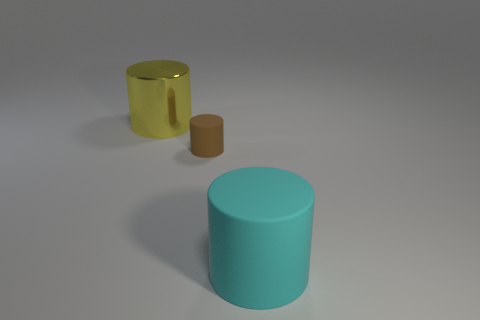Subtract all small cylinders. How many cylinders are left? 2 Add 1 yellow cylinders. How many objects exist? 4 Subtract all brown cylinders. How many cylinders are left? 2 Subtract 2 cylinders. How many cylinders are left? 1 Subtract all small green shiny cylinders. Subtract all large yellow cylinders. How many objects are left? 2 Add 1 rubber cylinders. How many rubber cylinders are left? 3 Add 3 brown rubber objects. How many brown rubber objects exist? 4 Subtract 1 yellow cylinders. How many objects are left? 2 Subtract all blue cylinders. Subtract all purple blocks. How many cylinders are left? 3 